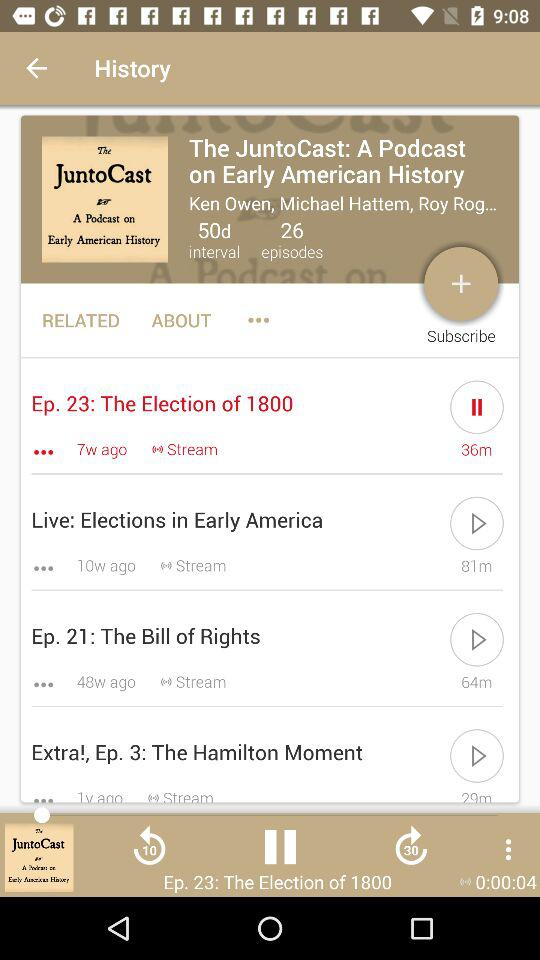When was "The Election of 1800" uploaded? It was uploaded 7 weeks ago. 